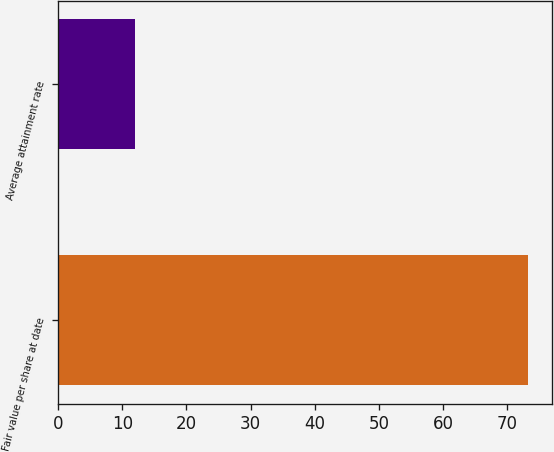Convert chart. <chart><loc_0><loc_0><loc_500><loc_500><bar_chart><fcel>Fair value per share at date<fcel>Average attainment rate<nl><fcel>73.28<fcel>11.98<nl></chart> 